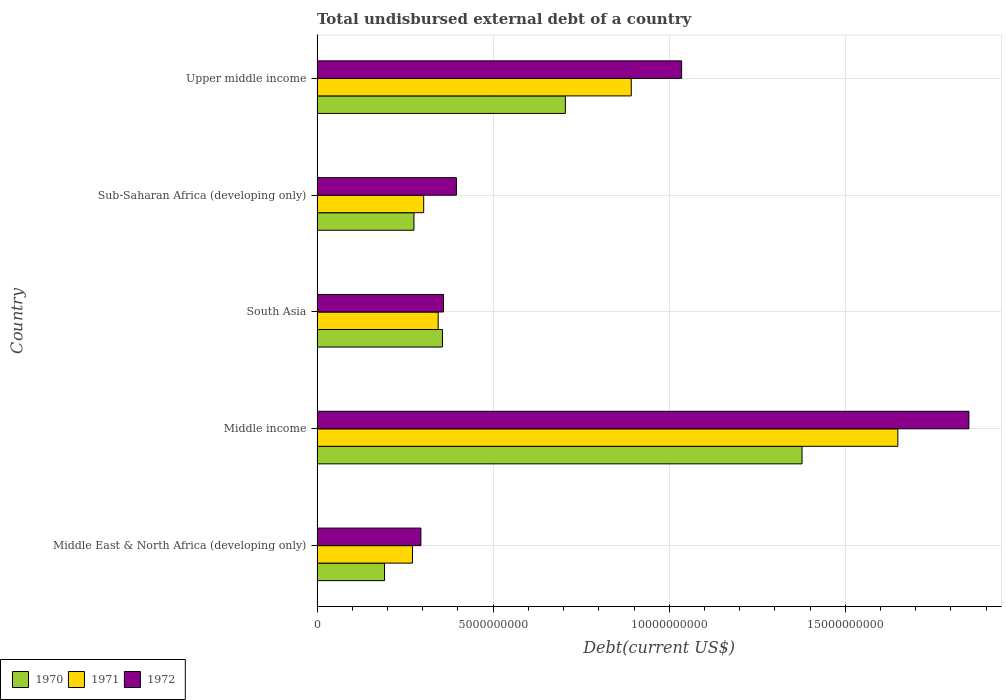Are the number of bars per tick equal to the number of legend labels?
Provide a short and direct response. Yes. Are the number of bars on each tick of the Y-axis equal?
Offer a terse response. Yes. What is the label of the 5th group of bars from the top?
Your answer should be compact. Middle East & North Africa (developing only). In how many cases, is the number of bars for a given country not equal to the number of legend labels?
Keep it short and to the point. 0. What is the total undisbursed external debt in 1972 in Middle income?
Provide a short and direct response. 1.85e+1. Across all countries, what is the maximum total undisbursed external debt in 1971?
Offer a very short reply. 1.65e+1. Across all countries, what is the minimum total undisbursed external debt in 1972?
Your response must be concise. 2.95e+09. In which country was the total undisbursed external debt in 1971 minimum?
Your answer should be very brief. Middle East & North Africa (developing only). What is the total total undisbursed external debt in 1970 in the graph?
Make the answer very short. 2.91e+1. What is the difference between the total undisbursed external debt in 1972 in Middle East & North Africa (developing only) and that in South Asia?
Your answer should be very brief. -6.42e+08. What is the difference between the total undisbursed external debt in 1972 in Upper middle income and the total undisbursed external debt in 1971 in Sub-Saharan Africa (developing only)?
Your answer should be compact. 7.32e+09. What is the average total undisbursed external debt in 1971 per country?
Your answer should be very brief. 6.92e+09. What is the difference between the total undisbursed external debt in 1970 and total undisbursed external debt in 1971 in Middle income?
Make the answer very short. -2.72e+09. In how many countries, is the total undisbursed external debt in 1970 greater than 10000000000 US$?
Provide a short and direct response. 1. What is the ratio of the total undisbursed external debt in 1970 in Middle East & North Africa (developing only) to that in Upper middle income?
Offer a terse response. 0.27. Is the difference between the total undisbursed external debt in 1970 in South Asia and Sub-Saharan Africa (developing only) greater than the difference between the total undisbursed external debt in 1971 in South Asia and Sub-Saharan Africa (developing only)?
Your answer should be very brief. Yes. What is the difference between the highest and the second highest total undisbursed external debt in 1970?
Provide a short and direct response. 6.72e+09. What is the difference between the highest and the lowest total undisbursed external debt in 1972?
Your answer should be compact. 1.56e+1. What does the 3rd bar from the top in South Asia represents?
Your response must be concise. 1970. What does the 3rd bar from the bottom in Sub-Saharan Africa (developing only) represents?
Offer a very short reply. 1972. Are all the bars in the graph horizontal?
Your response must be concise. Yes. How many countries are there in the graph?
Provide a succinct answer. 5. What is the difference between two consecutive major ticks on the X-axis?
Keep it short and to the point. 5.00e+09. Are the values on the major ticks of X-axis written in scientific E-notation?
Your answer should be very brief. No. Does the graph contain grids?
Offer a terse response. Yes. Where does the legend appear in the graph?
Provide a short and direct response. Bottom left. What is the title of the graph?
Give a very brief answer. Total undisbursed external debt of a country. What is the label or title of the X-axis?
Your response must be concise. Debt(current US$). What is the Debt(current US$) in 1970 in Middle East & North Africa (developing only)?
Your answer should be compact. 1.92e+09. What is the Debt(current US$) in 1971 in Middle East & North Africa (developing only)?
Ensure brevity in your answer.  2.71e+09. What is the Debt(current US$) in 1972 in Middle East & North Africa (developing only)?
Offer a terse response. 2.95e+09. What is the Debt(current US$) of 1970 in Middle income?
Make the answer very short. 1.38e+1. What is the Debt(current US$) in 1971 in Middle income?
Provide a short and direct response. 1.65e+1. What is the Debt(current US$) in 1972 in Middle income?
Provide a succinct answer. 1.85e+1. What is the Debt(current US$) of 1970 in South Asia?
Provide a short and direct response. 3.56e+09. What is the Debt(current US$) in 1971 in South Asia?
Your answer should be very brief. 3.44e+09. What is the Debt(current US$) of 1972 in South Asia?
Offer a terse response. 3.59e+09. What is the Debt(current US$) of 1970 in Sub-Saharan Africa (developing only)?
Offer a terse response. 2.75e+09. What is the Debt(current US$) in 1971 in Sub-Saharan Africa (developing only)?
Ensure brevity in your answer.  3.03e+09. What is the Debt(current US$) in 1972 in Sub-Saharan Africa (developing only)?
Your answer should be compact. 3.96e+09. What is the Debt(current US$) of 1970 in Upper middle income?
Your answer should be compact. 7.05e+09. What is the Debt(current US$) in 1971 in Upper middle income?
Your answer should be very brief. 8.92e+09. What is the Debt(current US$) in 1972 in Upper middle income?
Offer a very short reply. 1.04e+1. Across all countries, what is the maximum Debt(current US$) in 1970?
Your response must be concise. 1.38e+1. Across all countries, what is the maximum Debt(current US$) in 1971?
Make the answer very short. 1.65e+1. Across all countries, what is the maximum Debt(current US$) of 1972?
Your response must be concise. 1.85e+1. Across all countries, what is the minimum Debt(current US$) in 1970?
Offer a very short reply. 1.92e+09. Across all countries, what is the minimum Debt(current US$) in 1971?
Your answer should be very brief. 2.71e+09. Across all countries, what is the minimum Debt(current US$) in 1972?
Give a very brief answer. 2.95e+09. What is the total Debt(current US$) of 1970 in the graph?
Provide a succinct answer. 2.91e+1. What is the total Debt(current US$) in 1971 in the graph?
Offer a terse response. 3.46e+1. What is the total Debt(current US$) of 1972 in the graph?
Keep it short and to the point. 3.94e+1. What is the difference between the Debt(current US$) in 1970 in Middle East & North Africa (developing only) and that in Middle income?
Make the answer very short. -1.19e+1. What is the difference between the Debt(current US$) of 1971 in Middle East & North Africa (developing only) and that in Middle income?
Make the answer very short. -1.38e+1. What is the difference between the Debt(current US$) in 1972 in Middle East & North Africa (developing only) and that in Middle income?
Your answer should be very brief. -1.56e+1. What is the difference between the Debt(current US$) in 1970 in Middle East & North Africa (developing only) and that in South Asia?
Provide a short and direct response. -1.64e+09. What is the difference between the Debt(current US$) in 1971 in Middle East & North Africa (developing only) and that in South Asia?
Your response must be concise. -7.30e+08. What is the difference between the Debt(current US$) of 1972 in Middle East & North Africa (developing only) and that in South Asia?
Give a very brief answer. -6.42e+08. What is the difference between the Debt(current US$) in 1970 in Middle East & North Africa (developing only) and that in Sub-Saharan Africa (developing only)?
Give a very brief answer. -8.36e+08. What is the difference between the Debt(current US$) of 1971 in Middle East & North Africa (developing only) and that in Sub-Saharan Africa (developing only)?
Your response must be concise. -3.18e+08. What is the difference between the Debt(current US$) of 1972 in Middle East & North Africa (developing only) and that in Sub-Saharan Africa (developing only)?
Provide a succinct answer. -1.01e+09. What is the difference between the Debt(current US$) in 1970 in Middle East & North Africa (developing only) and that in Upper middle income?
Keep it short and to the point. -5.14e+09. What is the difference between the Debt(current US$) of 1971 in Middle East & North Africa (developing only) and that in Upper middle income?
Provide a short and direct response. -6.21e+09. What is the difference between the Debt(current US$) in 1972 in Middle East & North Africa (developing only) and that in Upper middle income?
Ensure brevity in your answer.  -7.40e+09. What is the difference between the Debt(current US$) in 1970 in Middle income and that in South Asia?
Give a very brief answer. 1.02e+1. What is the difference between the Debt(current US$) in 1971 in Middle income and that in South Asia?
Ensure brevity in your answer.  1.31e+1. What is the difference between the Debt(current US$) of 1972 in Middle income and that in South Asia?
Give a very brief answer. 1.49e+1. What is the difference between the Debt(current US$) of 1970 in Middle income and that in Sub-Saharan Africa (developing only)?
Make the answer very short. 1.10e+1. What is the difference between the Debt(current US$) of 1971 in Middle income and that in Sub-Saharan Africa (developing only)?
Your response must be concise. 1.35e+1. What is the difference between the Debt(current US$) of 1972 in Middle income and that in Sub-Saharan Africa (developing only)?
Provide a succinct answer. 1.46e+1. What is the difference between the Debt(current US$) in 1970 in Middle income and that in Upper middle income?
Your answer should be very brief. 6.72e+09. What is the difference between the Debt(current US$) in 1971 in Middle income and that in Upper middle income?
Your response must be concise. 7.57e+09. What is the difference between the Debt(current US$) in 1972 in Middle income and that in Upper middle income?
Provide a short and direct response. 8.16e+09. What is the difference between the Debt(current US$) of 1970 in South Asia and that in Sub-Saharan Africa (developing only)?
Give a very brief answer. 8.09e+08. What is the difference between the Debt(current US$) in 1971 in South Asia and that in Sub-Saharan Africa (developing only)?
Your answer should be very brief. 4.11e+08. What is the difference between the Debt(current US$) in 1972 in South Asia and that in Sub-Saharan Africa (developing only)?
Your answer should be very brief. -3.67e+08. What is the difference between the Debt(current US$) in 1970 in South Asia and that in Upper middle income?
Your answer should be compact. -3.49e+09. What is the difference between the Debt(current US$) of 1971 in South Asia and that in Upper middle income?
Your answer should be very brief. -5.48e+09. What is the difference between the Debt(current US$) of 1972 in South Asia and that in Upper middle income?
Provide a succinct answer. -6.76e+09. What is the difference between the Debt(current US$) of 1970 in Sub-Saharan Africa (developing only) and that in Upper middle income?
Your response must be concise. -4.30e+09. What is the difference between the Debt(current US$) of 1971 in Sub-Saharan Africa (developing only) and that in Upper middle income?
Provide a short and direct response. -5.89e+09. What is the difference between the Debt(current US$) of 1972 in Sub-Saharan Africa (developing only) and that in Upper middle income?
Your response must be concise. -6.39e+09. What is the difference between the Debt(current US$) in 1970 in Middle East & North Africa (developing only) and the Debt(current US$) in 1971 in Middle income?
Your answer should be very brief. -1.46e+1. What is the difference between the Debt(current US$) in 1970 in Middle East & North Africa (developing only) and the Debt(current US$) in 1972 in Middle income?
Your answer should be very brief. -1.66e+1. What is the difference between the Debt(current US$) of 1971 in Middle East & North Africa (developing only) and the Debt(current US$) of 1972 in Middle income?
Your response must be concise. -1.58e+1. What is the difference between the Debt(current US$) of 1970 in Middle East & North Africa (developing only) and the Debt(current US$) of 1971 in South Asia?
Make the answer very short. -1.52e+09. What is the difference between the Debt(current US$) in 1970 in Middle East & North Africa (developing only) and the Debt(current US$) in 1972 in South Asia?
Give a very brief answer. -1.67e+09. What is the difference between the Debt(current US$) of 1971 in Middle East & North Africa (developing only) and the Debt(current US$) of 1972 in South Asia?
Your response must be concise. -8.81e+08. What is the difference between the Debt(current US$) of 1970 in Middle East & North Africa (developing only) and the Debt(current US$) of 1971 in Sub-Saharan Africa (developing only)?
Provide a succinct answer. -1.11e+09. What is the difference between the Debt(current US$) of 1970 in Middle East & North Africa (developing only) and the Debt(current US$) of 1972 in Sub-Saharan Africa (developing only)?
Your answer should be very brief. -2.04e+09. What is the difference between the Debt(current US$) in 1971 in Middle East & North Africa (developing only) and the Debt(current US$) in 1972 in Sub-Saharan Africa (developing only)?
Provide a succinct answer. -1.25e+09. What is the difference between the Debt(current US$) of 1970 in Middle East & North Africa (developing only) and the Debt(current US$) of 1971 in Upper middle income?
Give a very brief answer. -7.01e+09. What is the difference between the Debt(current US$) in 1970 in Middle East & North Africa (developing only) and the Debt(current US$) in 1972 in Upper middle income?
Provide a short and direct response. -8.44e+09. What is the difference between the Debt(current US$) in 1971 in Middle East & North Africa (developing only) and the Debt(current US$) in 1972 in Upper middle income?
Keep it short and to the point. -7.64e+09. What is the difference between the Debt(current US$) of 1970 in Middle income and the Debt(current US$) of 1971 in South Asia?
Make the answer very short. 1.03e+1. What is the difference between the Debt(current US$) in 1970 in Middle income and the Debt(current US$) in 1972 in South Asia?
Your response must be concise. 1.02e+1. What is the difference between the Debt(current US$) in 1971 in Middle income and the Debt(current US$) in 1972 in South Asia?
Provide a short and direct response. 1.29e+1. What is the difference between the Debt(current US$) of 1970 in Middle income and the Debt(current US$) of 1971 in Sub-Saharan Africa (developing only)?
Provide a short and direct response. 1.07e+1. What is the difference between the Debt(current US$) of 1970 in Middle income and the Debt(current US$) of 1972 in Sub-Saharan Africa (developing only)?
Your answer should be compact. 9.81e+09. What is the difference between the Debt(current US$) in 1971 in Middle income and the Debt(current US$) in 1972 in Sub-Saharan Africa (developing only)?
Your answer should be very brief. 1.25e+1. What is the difference between the Debt(current US$) in 1970 in Middle income and the Debt(current US$) in 1971 in Upper middle income?
Provide a succinct answer. 4.85e+09. What is the difference between the Debt(current US$) of 1970 in Middle income and the Debt(current US$) of 1972 in Upper middle income?
Give a very brief answer. 3.42e+09. What is the difference between the Debt(current US$) of 1971 in Middle income and the Debt(current US$) of 1972 in Upper middle income?
Your response must be concise. 6.14e+09. What is the difference between the Debt(current US$) in 1970 in South Asia and the Debt(current US$) in 1971 in Sub-Saharan Africa (developing only)?
Your answer should be compact. 5.33e+08. What is the difference between the Debt(current US$) in 1970 in South Asia and the Debt(current US$) in 1972 in Sub-Saharan Africa (developing only)?
Your response must be concise. -3.97e+08. What is the difference between the Debt(current US$) of 1971 in South Asia and the Debt(current US$) of 1972 in Sub-Saharan Africa (developing only)?
Offer a terse response. -5.18e+08. What is the difference between the Debt(current US$) in 1970 in South Asia and the Debt(current US$) in 1971 in Upper middle income?
Provide a short and direct response. -5.36e+09. What is the difference between the Debt(current US$) in 1970 in South Asia and the Debt(current US$) in 1972 in Upper middle income?
Ensure brevity in your answer.  -6.79e+09. What is the difference between the Debt(current US$) in 1971 in South Asia and the Debt(current US$) in 1972 in Upper middle income?
Provide a succinct answer. -6.91e+09. What is the difference between the Debt(current US$) in 1970 in Sub-Saharan Africa (developing only) and the Debt(current US$) in 1971 in Upper middle income?
Make the answer very short. -6.17e+09. What is the difference between the Debt(current US$) of 1970 in Sub-Saharan Africa (developing only) and the Debt(current US$) of 1972 in Upper middle income?
Make the answer very short. -7.60e+09. What is the difference between the Debt(current US$) of 1971 in Sub-Saharan Africa (developing only) and the Debt(current US$) of 1972 in Upper middle income?
Keep it short and to the point. -7.32e+09. What is the average Debt(current US$) of 1970 per country?
Ensure brevity in your answer.  5.81e+09. What is the average Debt(current US$) in 1971 per country?
Ensure brevity in your answer.  6.92e+09. What is the average Debt(current US$) of 1972 per country?
Provide a succinct answer. 7.87e+09. What is the difference between the Debt(current US$) in 1970 and Debt(current US$) in 1971 in Middle East & North Africa (developing only)?
Make the answer very short. -7.94e+08. What is the difference between the Debt(current US$) of 1970 and Debt(current US$) of 1972 in Middle East & North Africa (developing only)?
Offer a very short reply. -1.03e+09. What is the difference between the Debt(current US$) of 1971 and Debt(current US$) of 1972 in Middle East & North Africa (developing only)?
Your response must be concise. -2.39e+08. What is the difference between the Debt(current US$) in 1970 and Debt(current US$) in 1971 in Middle income?
Ensure brevity in your answer.  -2.72e+09. What is the difference between the Debt(current US$) in 1970 and Debt(current US$) in 1972 in Middle income?
Make the answer very short. -4.74e+09. What is the difference between the Debt(current US$) in 1971 and Debt(current US$) in 1972 in Middle income?
Offer a very short reply. -2.02e+09. What is the difference between the Debt(current US$) of 1970 and Debt(current US$) of 1971 in South Asia?
Your answer should be very brief. 1.21e+08. What is the difference between the Debt(current US$) of 1970 and Debt(current US$) of 1972 in South Asia?
Your answer should be very brief. -3.02e+07. What is the difference between the Debt(current US$) of 1971 and Debt(current US$) of 1972 in South Asia?
Your answer should be very brief. -1.51e+08. What is the difference between the Debt(current US$) of 1970 and Debt(current US$) of 1971 in Sub-Saharan Africa (developing only)?
Keep it short and to the point. -2.76e+08. What is the difference between the Debt(current US$) in 1970 and Debt(current US$) in 1972 in Sub-Saharan Africa (developing only)?
Offer a terse response. -1.21e+09. What is the difference between the Debt(current US$) of 1971 and Debt(current US$) of 1972 in Sub-Saharan Africa (developing only)?
Make the answer very short. -9.29e+08. What is the difference between the Debt(current US$) of 1970 and Debt(current US$) of 1971 in Upper middle income?
Make the answer very short. -1.87e+09. What is the difference between the Debt(current US$) of 1970 and Debt(current US$) of 1972 in Upper middle income?
Your answer should be very brief. -3.30e+09. What is the difference between the Debt(current US$) in 1971 and Debt(current US$) in 1972 in Upper middle income?
Your response must be concise. -1.43e+09. What is the ratio of the Debt(current US$) of 1970 in Middle East & North Africa (developing only) to that in Middle income?
Provide a short and direct response. 0.14. What is the ratio of the Debt(current US$) of 1971 in Middle East & North Africa (developing only) to that in Middle income?
Offer a terse response. 0.16. What is the ratio of the Debt(current US$) of 1972 in Middle East & North Africa (developing only) to that in Middle income?
Give a very brief answer. 0.16. What is the ratio of the Debt(current US$) in 1970 in Middle East & North Africa (developing only) to that in South Asia?
Your answer should be compact. 0.54. What is the ratio of the Debt(current US$) in 1971 in Middle East & North Africa (developing only) to that in South Asia?
Ensure brevity in your answer.  0.79. What is the ratio of the Debt(current US$) in 1972 in Middle East & North Africa (developing only) to that in South Asia?
Your response must be concise. 0.82. What is the ratio of the Debt(current US$) of 1970 in Middle East & North Africa (developing only) to that in Sub-Saharan Africa (developing only)?
Your answer should be compact. 0.7. What is the ratio of the Debt(current US$) in 1971 in Middle East & North Africa (developing only) to that in Sub-Saharan Africa (developing only)?
Your answer should be compact. 0.89. What is the ratio of the Debt(current US$) in 1972 in Middle East & North Africa (developing only) to that in Sub-Saharan Africa (developing only)?
Your response must be concise. 0.75. What is the ratio of the Debt(current US$) of 1970 in Middle East & North Africa (developing only) to that in Upper middle income?
Give a very brief answer. 0.27. What is the ratio of the Debt(current US$) in 1971 in Middle East & North Africa (developing only) to that in Upper middle income?
Your answer should be very brief. 0.3. What is the ratio of the Debt(current US$) in 1972 in Middle East & North Africa (developing only) to that in Upper middle income?
Ensure brevity in your answer.  0.28. What is the ratio of the Debt(current US$) of 1970 in Middle income to that in South Asia?
Give a very brief answer. 3.87. What is the ratio of the Debt(current US$) of 1971 in Middle income to that in South Asia?
Make the answer very short. 4.8. What is the ratio of the Debt(current US$) in 1972 in Middle income to that in South Asia?
Provide a short and direct response. 5.15. What is the ratio of the Debt(current US$) of 1970 in Middle income to that in Sub-Saharan Africa (developing only)?
Make the answer very short. 5. What is the ratio of the Debt(current US$) in 1971 in Middle income to that in Sub-Saharan Africa (developing only)?
Your response must be concise. 5.45. What is the ratio of the Debt(current US$) of 1972 in Middle income to that in Sub-Saharan Africa (developing only)?
Give a very brief answer. 4.68. What is the ratio of the Debt(current US$) of 1970 in Middle income to that in Upper middle income?
Offer a terse response. 1.95. What is the ratio of the Debt(current US$) of 1971 in Middle income to that in Upper middle income?
Offer a very short reply. 1.85. What is the ratio of the Debt(current US$) in 1972 in Middle income to that in Upper middle income?
Keep it short and to the point. 1.79. What is the ratio of the Debt(current US$) of 1970 in South Asia to that in Sub-Saharan Africa (developing only)?
Give a very brief answer. 1.29. What is the ratio of the Debt(current US$) of 1971 in South Asia to that in Sub-Saharan Africa (developing only)?
Ensure brevity in your answer.  1.14. What is the ratio of the Debt(current US$) of 1972 in South Asia to that in Sub-Saharan Africa (developing only)?
Provide a succinct answer. 0.91. What is the ratio of the Debt(current US$) of 1970 in South Asia to that in Upper middle income?
Your response must be concise. 0.5. What is the ratio of the Debt(current US$) of 1971 in South Asia to that in Upper middle income?
Ensure brevity in your answer.  0.39. What is the ratio of the Debt(current US$) in 1972 in South Asia to that in Upper middle income?
Your answer should be compact. 0.35. What is the ratio of the Debt(current US$) in 1970 in Sub-Saharan Africa (developing only) to that in Upper middle income?
Ensure brevity in your answer.  0.39. What is the ratio of the Debt(current US$) of 1971 in Sub-Saharan Africa (developing only) to that in Upper middle income?
Your response must be concise. 0.34. What is the ratio of the Debt(current US$) of 1972 in Sub-Saharan Africa (developing only) to that in Upper middle income?
Ensure brevity in your answer.  0.38. What is the difference between the highest and the second highest Debt(current US$) in 1970?
Offer a very short reply. 6.72e+09. What is the difference between the highest and the second highest Debt(current US$) in 1971?
Your answer should be very brief. 7.57e+09. What is the difference between the highest and the second highest Debt(current US$) of 1972?
Keep it short and to the point. 8.16e+09. What is the difference between the highest and the lowest Debt(current US$) in 1970?
Offer a terse response. 1.19e+1. What is the difference between the highest and the lowest Debt(current US$) of 1971?
Your answer should be very brief. 1.38e+1. What is the difference between the highest and the lowest Debt(current US$) of 1972?
Provide a succinct answer. 1.56e+1. 